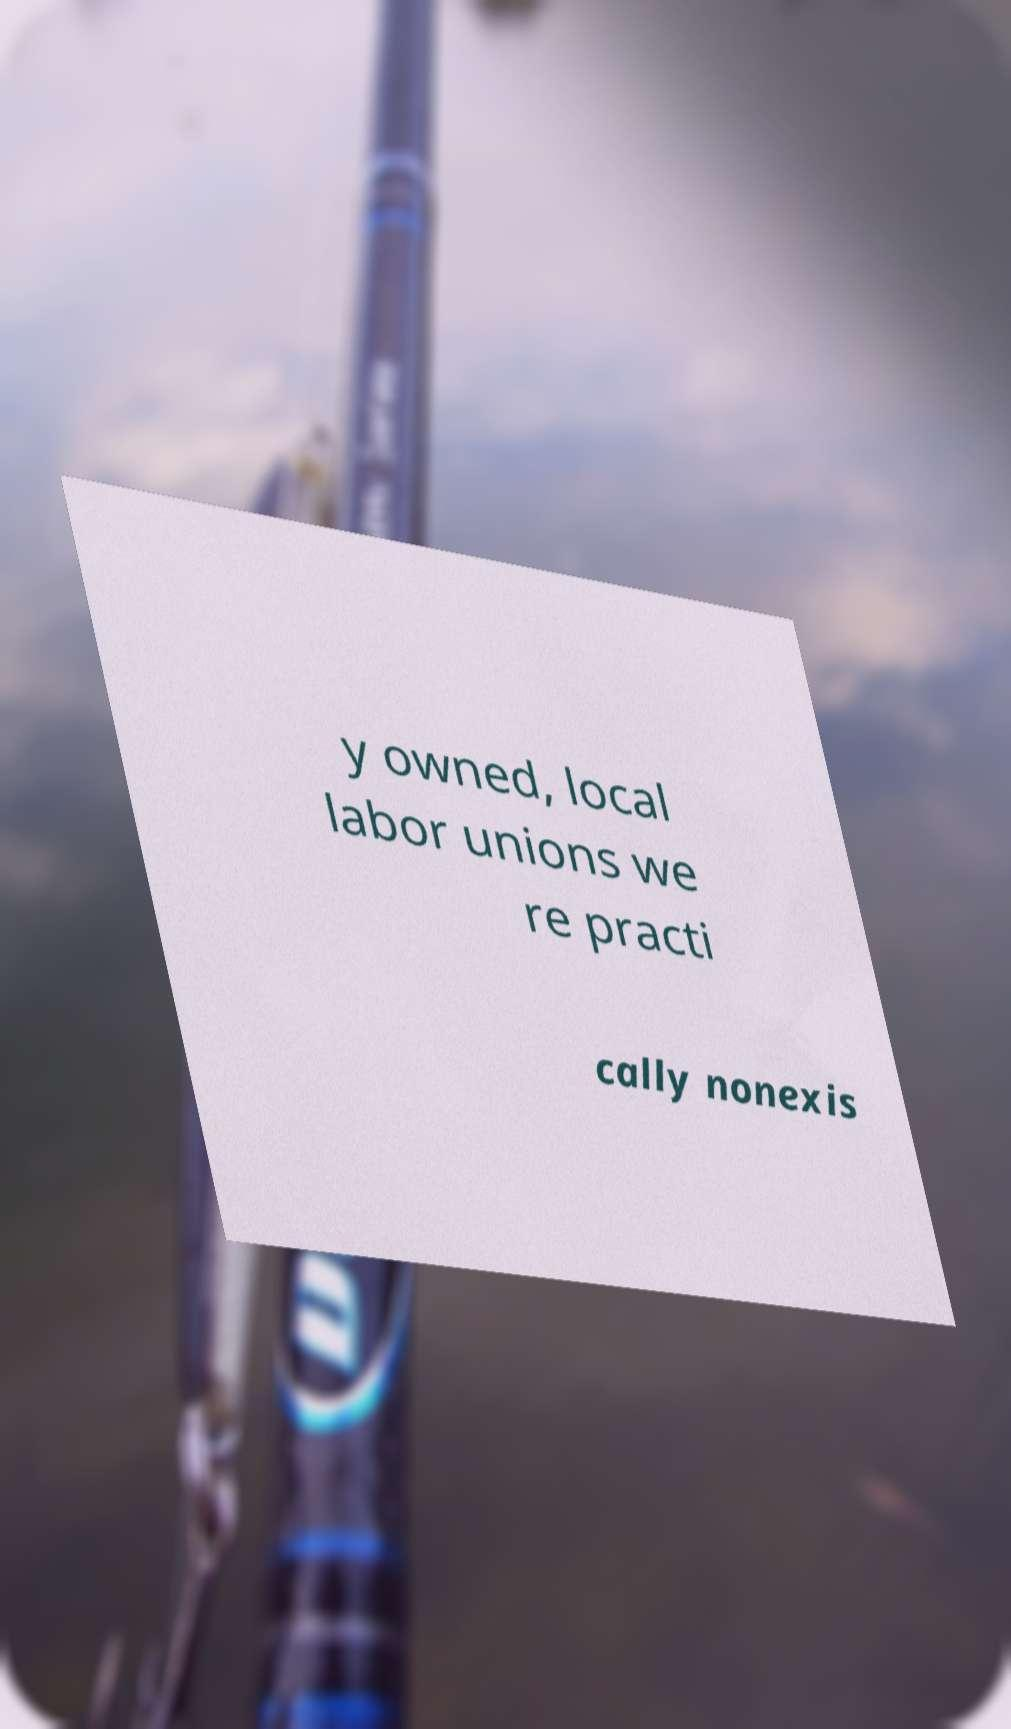Could you extract and type out the text from this image? y owned, local labor unions we re practi cally nonexis 